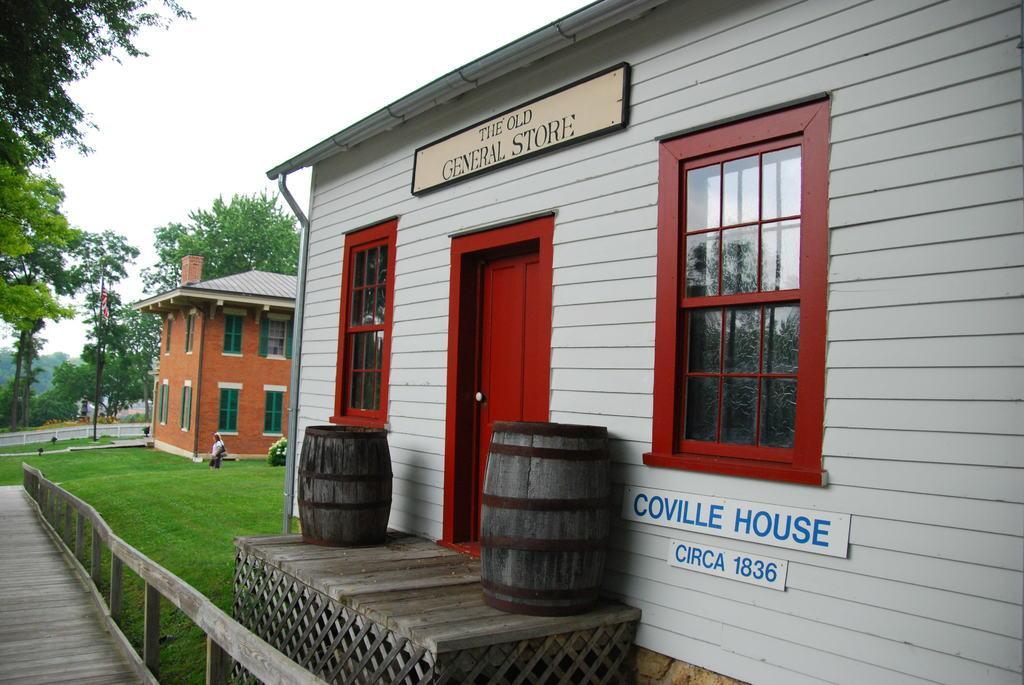Describe this image in one or two sentences. In this image, there are a few houses. We can see the ground with grass. We can also see the fence and a person. We can see some boards with text. We can see some trees and plants. We can also see a few wooden barrels on an object. We can also see the sky. We can see a pole. 